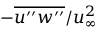Convert formula to latex. <formula><loc_0><loc_0><loc_500><loc_500>- \overline { { u ^ { \prime \prime } w ^ { \prime \prime } } } / u _ { \infty } ^ { 2 }</formula> 